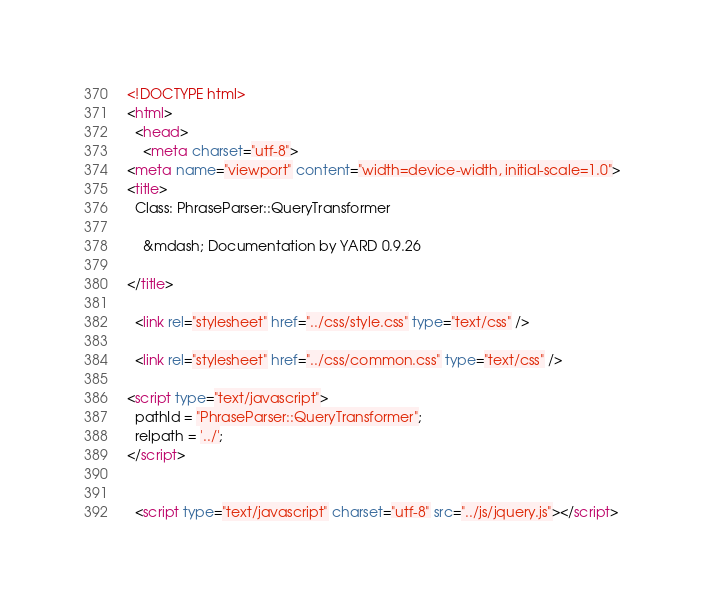Convert code to text. <code><loc_0><loc_0><loc_500><loc_500><_HTML_><!DOCTYPE html>
<html>
  <head>
    <meta charset="utf-8">
<meta name="viewport" content="width=device-width, initial-scale=1.0">
<title>
  Class: PhraseParser::QueryTransformer
  
    &mdash; Documentation by YARD 0.9.26
  
</title>

  <link rel="stylesheet" href="../css/style.css" type="text/css" />

  <link rel="stylesheet" href="../css/common.css" type="text/css" />

<script type="text/javascript">
  pathId = "PhraseParser::QueryTransformer";
  relpath = '../';
</script>


  <script type="text/javascript" charset="utf-8" src="../js/jquery.js"></script>
</code> 